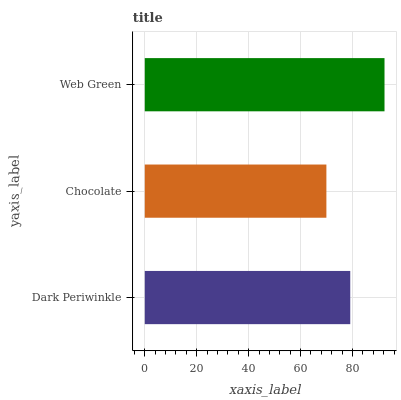Is Chocolate the minimum?
Answer yes or no. Yes. Is Web Green the maximum?
Answer yes or no. Yes. Is Web Green the minimum?
Answer yes or no. No. Is Chocolate the maximum?
Answer yes or no. No. Is Web Green greater than Chocolate?
Answer yes or no. Yes. Is Chocolate less than Web Green?
Answer yes or no. Yes. Is Chocolate greater than Web Green?
Answer yes or no. No. Is Web Green less than Chocolate?
Answer yes or no. No. Is Dark Periwinkle the high median?
Answer yes or no. Yes. Is Dark Periwinkle the low median?
Answer yes or no. Yes. Is Web Green the high median?
Answer yes or no. No. Is Chocolate the low median?
Answer yes or no. No. 